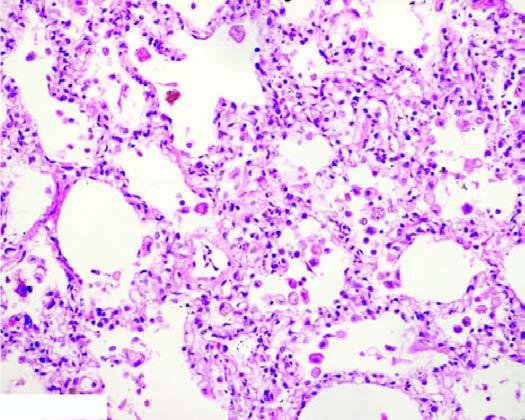what contain heart failure cells alveolar macrophages containing haemosiderin pigment?
Answer the question using a single word or phrase. The alveolar lumina 